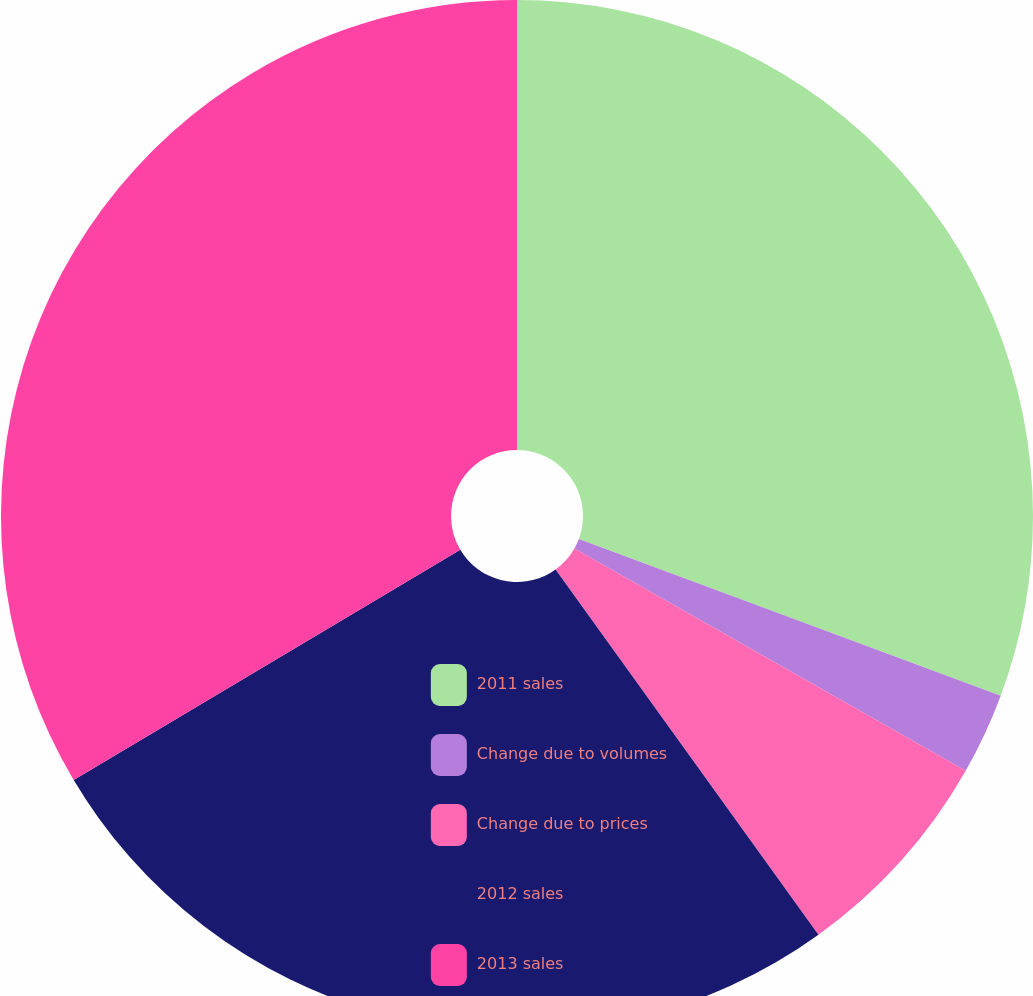Convert chart. <chart><loc_0><loc_0><loc_500><loc_500><pie_chart><fcel>2011 sales<fcel>Change due to volumes<fcel>Change due to prices<fcel>2012 sales<fcel>2013 sales<nl><fcel>30.66%<fcel>2.56%<fcel>6.85%<fcel>26.38%<fcel>33.55%<nl></chart> 